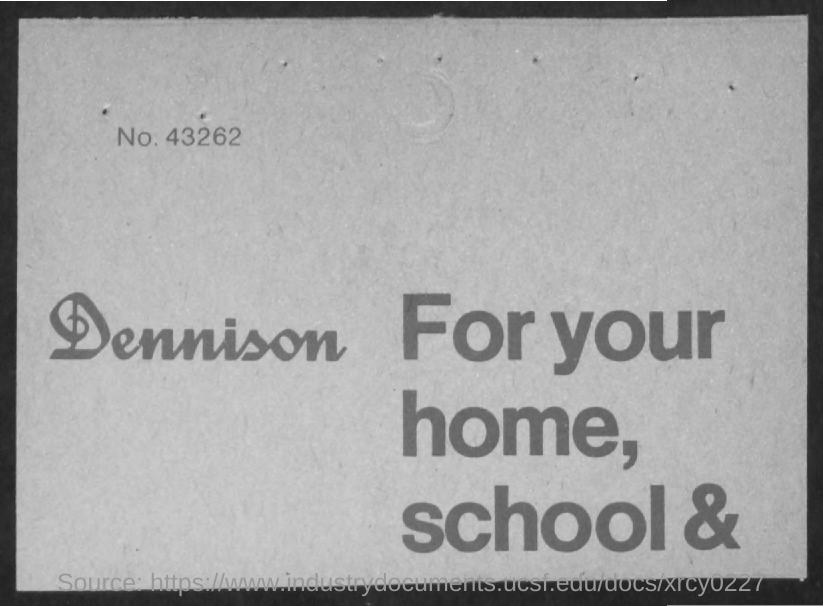What is the number?
Ensure brevity in your answer.  43262. 